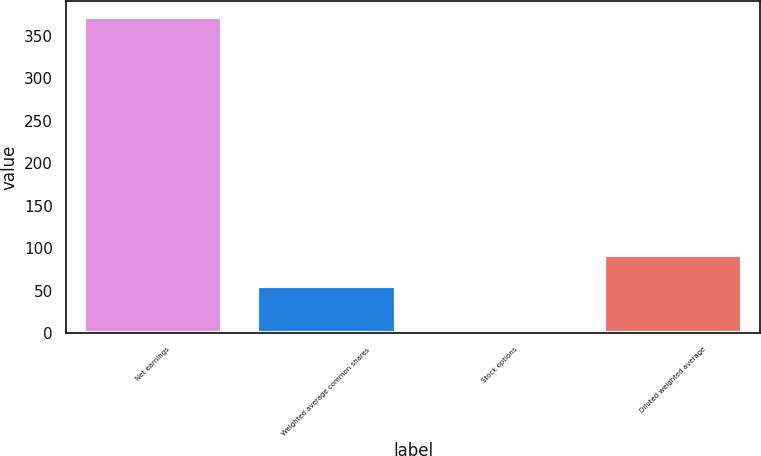Convert chart. <chart><loc_0><loc_0><loc_500><loc_500><bar_chart><fcel>Net earnings<fcel>Weighted average common shares<fcel>Stock options<fcel>Diluted weighted average<nl><fcel>372.7<fcel>55.5<fcel>1.1<fcel>92.66<nl></chart> 